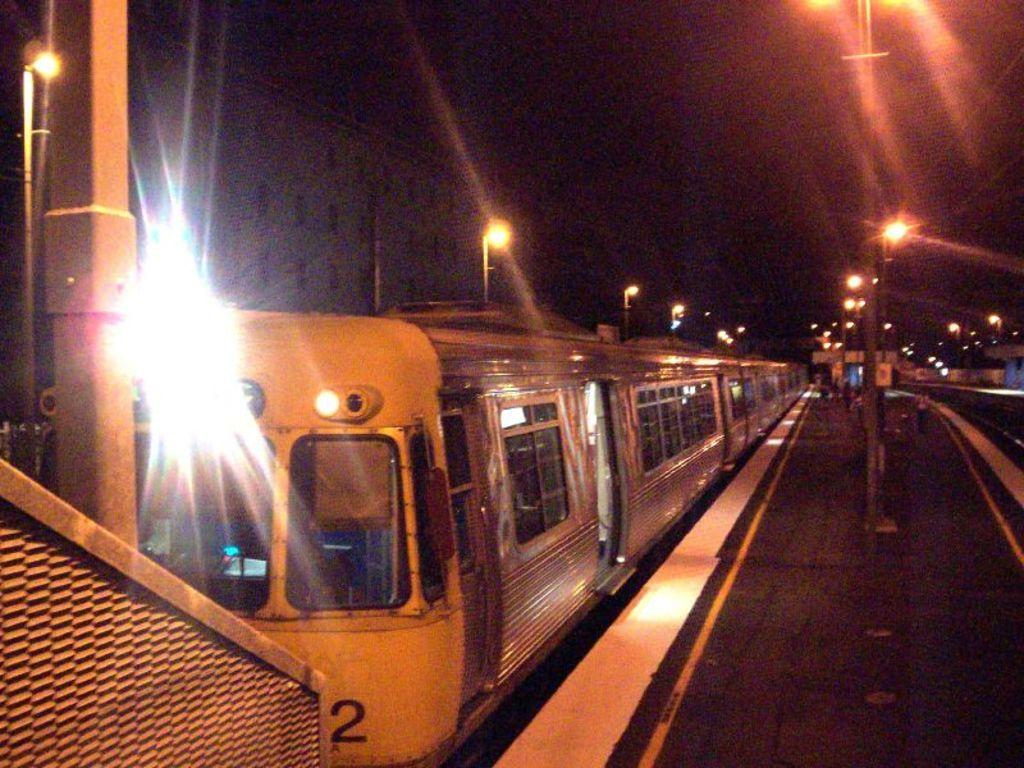Provide a one-sentence caption for the provided image. the number two on the front of a train. 